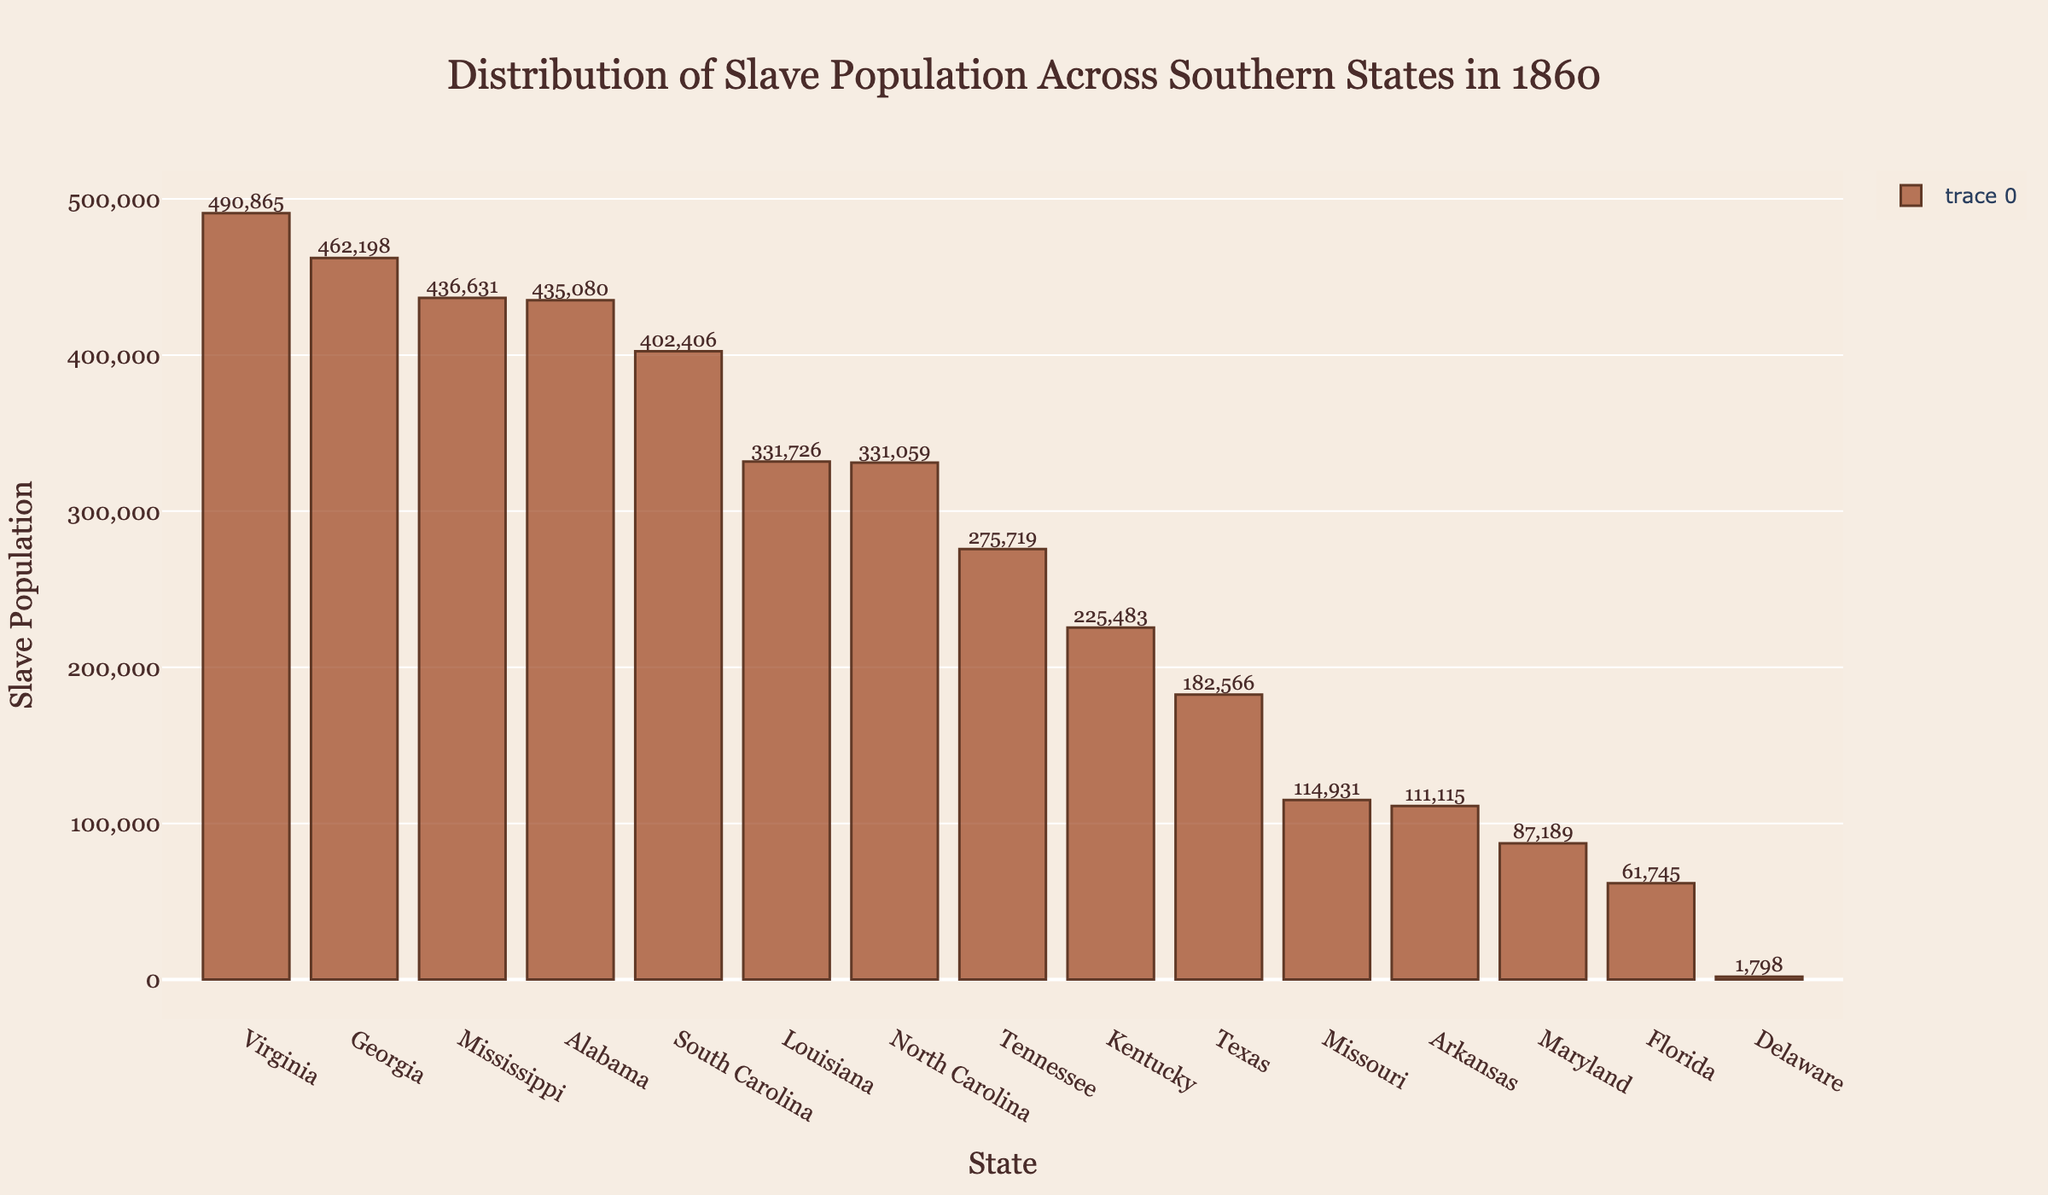Which state had the highest slave population in 1860? The highest bar indicates the state with the most slaves. In the figure, Virginia has the tallest bar.
Answer: Virginia How many states had a slave population greater than 400,000? To find this, look at the bars that reach above the 400,000 mark. The bars for Virginia, Georgia, Mississippi, Alabama, and South Carolina are the ones meeting this criterion.
Answer: 5 What was the average slave population of Arkansas and Maryland in 1860? Add the slave populations of Arkansas (111,115) and Maryland (87,189) and divide by 2. The calculation is (111,115 + 87,189) / 2.
Answer: 99,152 Which state had a lower slave population: Texas or Tennessee? Comparing the heights of the bars representing Texas and Tennessee, Texas has a shorter bar.
Answer: Texas What is the combined slave population of Louisiana and North Carolina in 1860? Sum the slave populations of Louisiana (331,726) and North Carolina (331,059).
Answer: 662,785 Is the slave population of Alabama greater than the combined populations of Missouri and Arkansas? Compare Alabama’s population (435,080) to the sum of Missouri (114,931) and Arkansas (111,115), which is 226,046. Alabama's population is clearly larger.
Answer: Yes What is the rank of Kentucky in terms of slave population? Sort the states by their slave population, and observe Kentucky's rank. It's the 9th highest.
Answer: 9 How many states had a slave population less than 100,000? Count the bars that do not reach the 100,000 mark. These include Missouri, Arkansas, Maryland, Florida, and Delaware.
Answer: 5 Which states had nearly the same slave population in 1860? Look for bars with similar heights. Louisiana (331,726) and North Carolina (331,059) have closely matching values.
Answer: Louisiana and North Carolina 